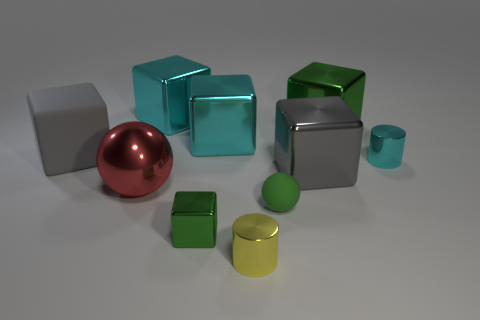Subtract 3 blocks. How many blocks are left? 3 Subtract all gray metal blocks. How many blocks are left? 5 Subtract all purple cubes. Subtract all blue balls. How many cubes are left? 6 Subtract all blocks. How many objects are left? 4 Subtract all large gray matte spheres. Subtract all red metallic things. How many objects are left? 9 Add 2 big rubber things. How many big rubber things are left? 3 Add 7 big green metal things. How many big green metal things exist? 8 Subtract 0 purple balls. How many objects are left? 10 